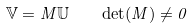Convert formula to latex. <formula><loc_0><loc_0><loc_500><loc_500>\mathbb { V } = M \mathbb { U } \quad \det ( M ) \ne 0</formula> 